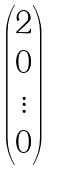<formula> <loc_0><loc_0><loc_500><loc_500>\begin{pmatrix} 2 \\ 0 \\ \vdots \\ 0 \end{pmatrix}</formula> 